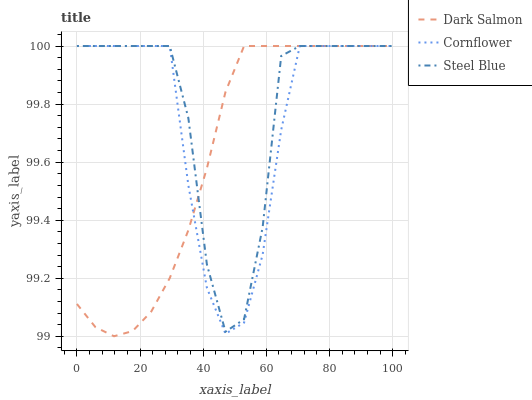Does Steel Blue have the minimum area under the curve?
Answer yes or no. No. Does Dark Salmon have the maximum area under the curve?
Answer yes or no. No. Is Steel Blue the smoothest?
Answer yes or no. No. Is Dark Salmon the roughest?
Answer yes or no. No. Does Steel Blue have the lowest value?
Answer yes or no. No. 